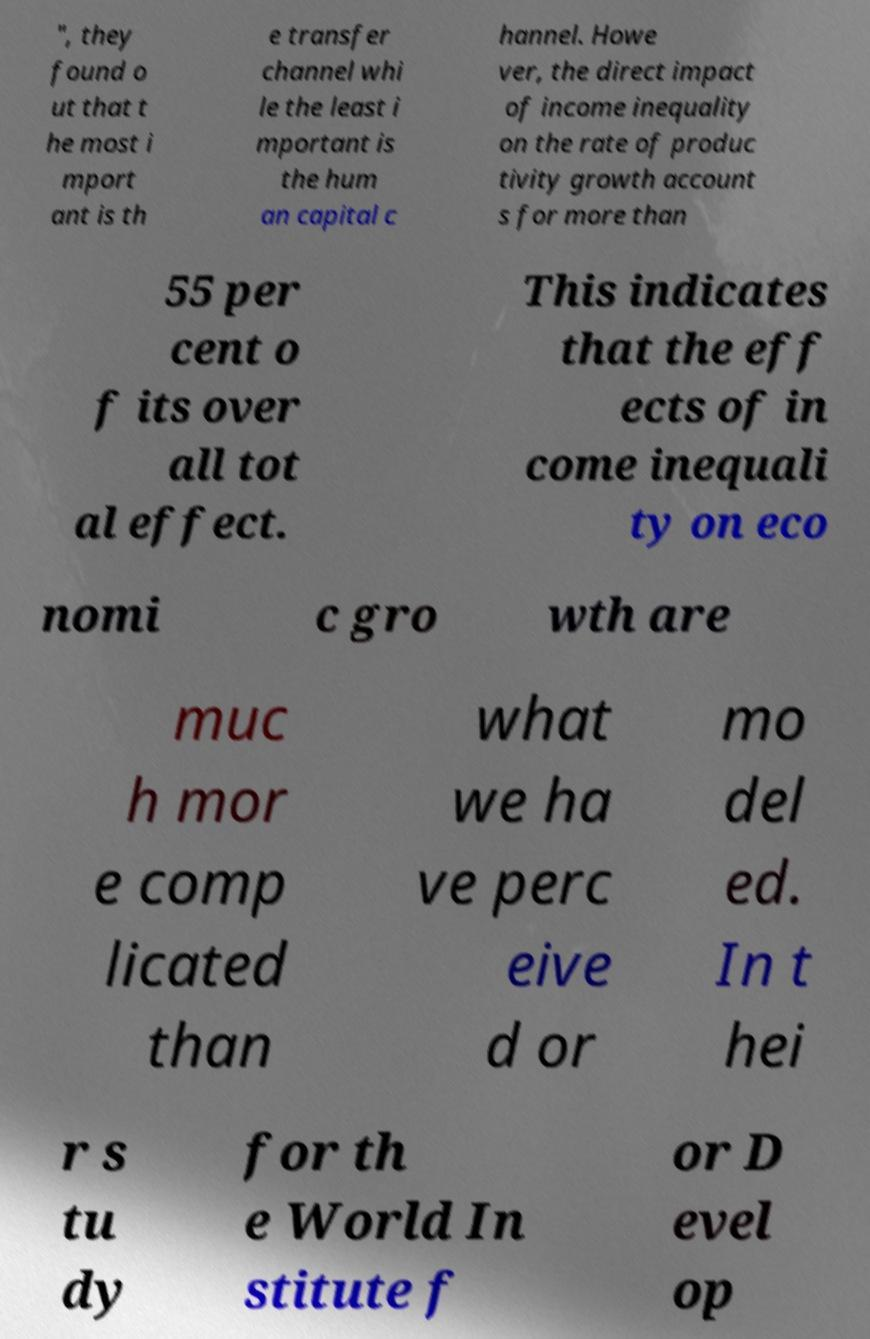Please identify and transcribe the text found in this image. ", they found o ut that t he most i mport ant is th e transfer channel whi le the least i mportant is the hum an capital c hannel. Howe ver, the direct impact of income inequality on the rate of produc tivity growth account s for more than 55 per cent o f its over all tot al effect. This indicates that the eff ects of in come inequali ty on eco nomi c gro wth are muc h mor e comp licated than what we ha ve perc eive d or mo del ed. In t hei r s tu dy for th e World In stitute f or D evel op 